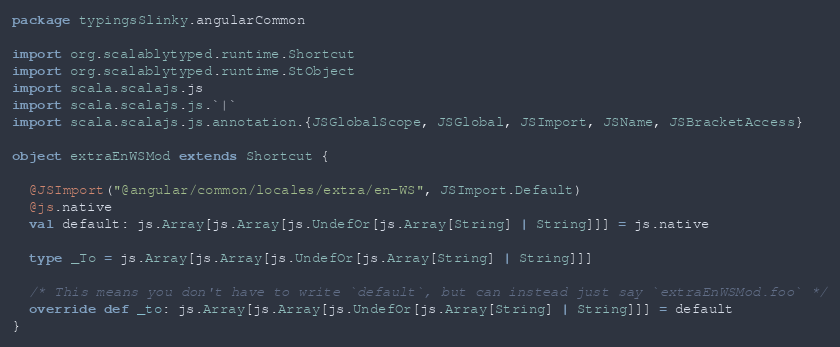Convert code to text. <code><loc_0><loc_0><loc_500><loc_500><_Scala_>package typingsSlinky.angularCommon

import org.scalablytyped.runtime.Shortcut
import org.scalablytyped.runtime.StObject
import scala.scalajs.js
import scala.scalajs.js.`|`
import scala.scalajs.js.annotation.{JSGlobalScope, JSGlobal, JSImport, JSName, JSBracketAccess}

object extraEnWSMod extends Shortcut {
  
  @JSImport("@angular/common/locales/extra/en-WS", JSImport.Default)
  @js.native
  val default: js.Array[js.Array[js.UndefOr[js.Array[String] | String]]] = js.native
  
  type _To = js.Array[js.Array[js.UndefOr[js.Array[String] | String]]]
  
  /* This means you don't have to write `default`, but can instead just say `extraEnWSMod.foo` */
  override def _to: js.Array[js.Array[js.UndefOr[js.Array[String] | String]]] = default
}
</code> 